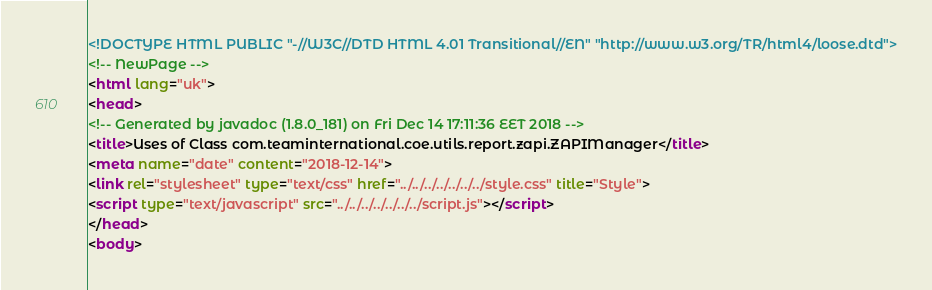Convert code to text. <code><loc_0><loc_0><loc_500><loc_500><_HTML_><!DOCTYPE HTML PUBLIC "-//W3C//DTD HTML 4.01 Transitional//EN" "http://www.w3.org/TR/html4/loose.dtd">
<!-- NewPage -->
<html lang="uk">
<head>
<!-- Generated by javadoc (1.8.0_181) on Fri Dec 14 17:11:36 EET 2018 -->
<title>Uses of Class com.teaminternational.coe.utils.report.zapi.ZAPIManager</title>
<meta name="date" content="2018-12-14">
<link rel="stylesheet" type="text/css" href="../../../../../../../style.css" title="Style">
<script type="text/javascript" src="../../../../../../../script.js"></script>
</head>
<body></code> 